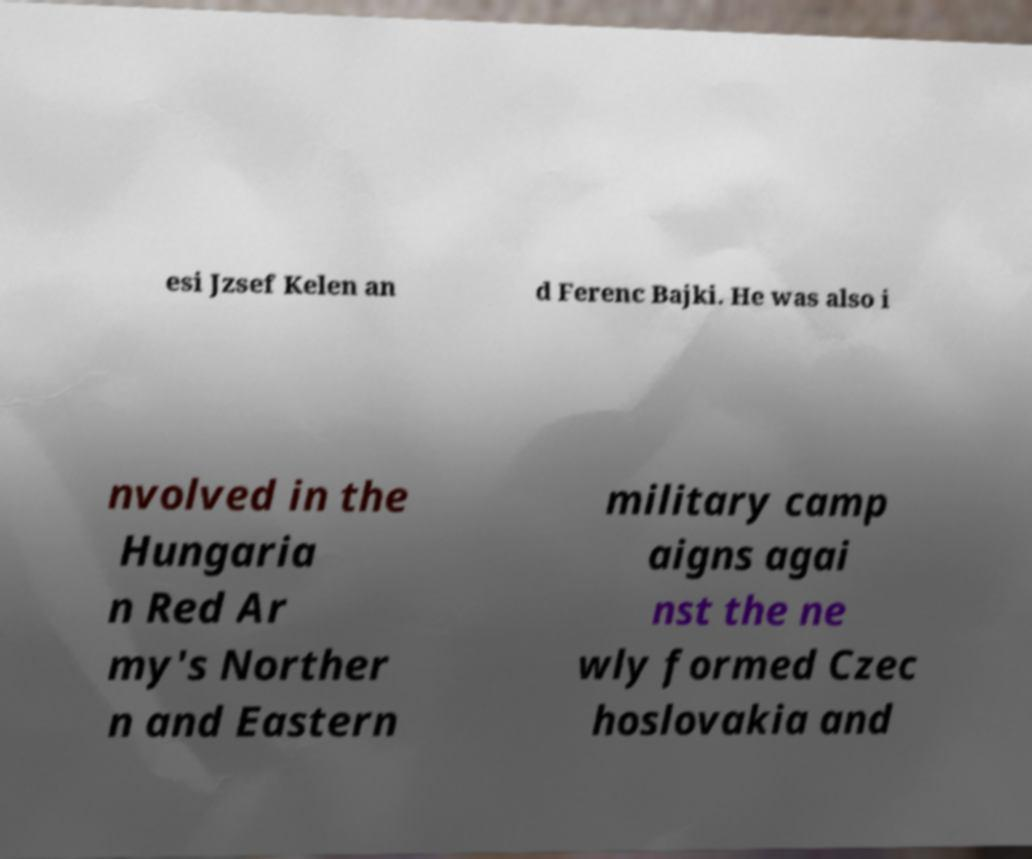What messages or text are displayed in this image? I need them in a readable, typed format. esi Jzsef Kelen an d Ferenc Bajki. He was also i nvolved in the Hungaria n Red Ar my's Norther n and Eastern military camp aigns agai nst the ne wly formed Czec hoslovakia and 